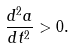<formula> <loc_0><loc_0><loc_500><loc_500>\frac { d ^ { 2 } a } { d t ^ { 2 } } > 0 .</formula> 